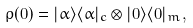<formula> <loc_0><loc_0><loc_500><loc_500>\rho ( 0 ) = | \alpha \rangle \langle \alpha | _ { c } \otimes | 0 \rangle \langle 0 | _ { m } ,</formula> 